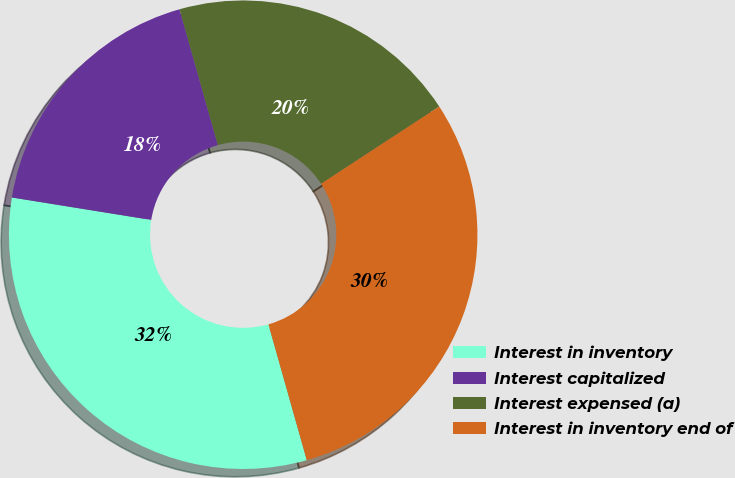Convert chart. <chart><loc_0><loc_0><loc_500><loc_500><pie_chart><fcel>Interest in inventory<fcel>Interest capitalized<fcel>Interest expensed (a)<fcel>Interest in inventory end of<nl><fcel>31.92%<fcel>18.08%<fcel>20.16%<fcel>29.84%<nl></chart> 